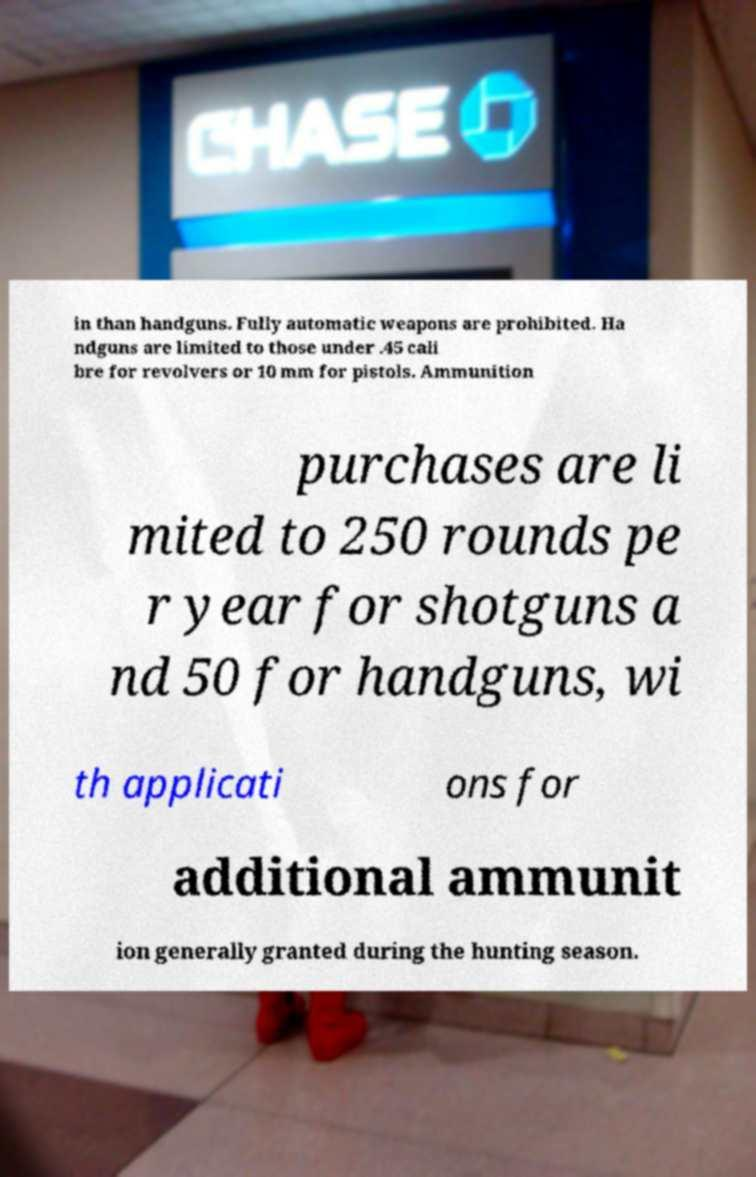Could you extract and type out the text from this image? in than handguns. Fully automatic weapons are prohibited. Ha ndguns are limited to those under .45 cali bre for revolvers or 10 mm for pistols. Ammunition purchases are li mited to 250 rounds pe r year for shotguns a nd 50 for handguns, wi th applicati ons for additional ammunit ion generally granted during the hunting season. 